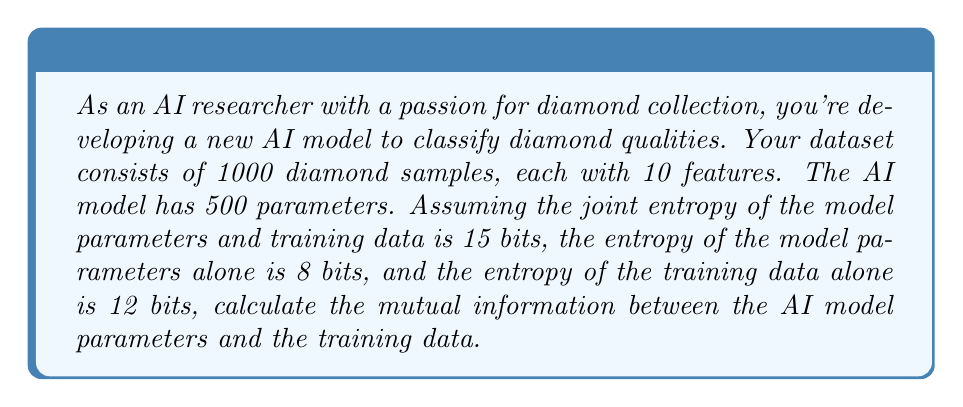Help me with this question. To solve this problem, we'll use the concept of mutual information from information theory. Mutual information measures the amount of information shared between two random variables. In this case, we're looking at the mutual information between the AI model parameters and the training data.

Let's define our variables:
- X: AI model parameters
- Y: Training data

We're given:
1. $H(X,Y) = 15$ bits (joint entropy)
2. $H(X) = 8$ bits (entropy of model parameters)
3. $H(Y) = 12$ bits (entropy of training data)

The formula for mutual information is:

$$I(X;Y) = H(X) + H(Y) - H(X,Y)$$

Where:
- $I(X;Y)$ is the mutual information between X and Y
- $H(X)$ is the entropy of X
- $H(Y)$ is the entropy of Y
- $H(X,Y)$ is the joint entropy of X and Y

Let's substitute the given values:

$$I(X;Y) = 8 + 12 - 15$$

$$I(X;Y) = 20 - 15$$

$$I(X;Y) = 5$$

Therefore, the mutual information between the AI model parameters and the training data is 5 bits.

This result indicates that there are 5 bits of shared information between the model parameters and the training data. In the context of AI and diamond classification, this suggests that the model parameters have captured a significant amount of information from the training data, which could lead to good performance in classifying diamond qualities.
Answer: 5 bits 